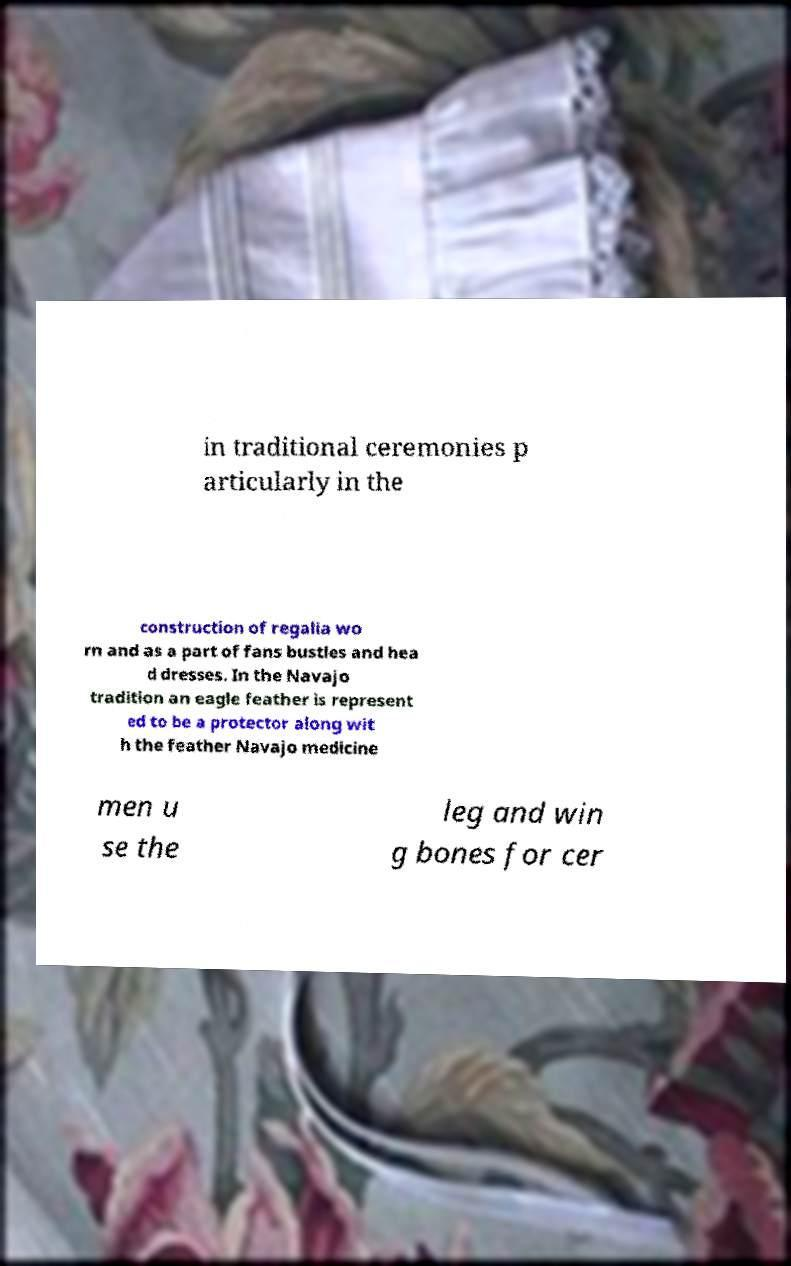There's text embedded in this image that I need extracted. Can you transcribe it verbatim? in traditional ceremonies p articularly in the construction of regalia wo rn and as a part of fans bustles and hea d dresses. In the Navajo tradition an eagle feather is represent ed to be a protector along wit h the feather Navajo medicine men u se the leg and win g bones for cer 